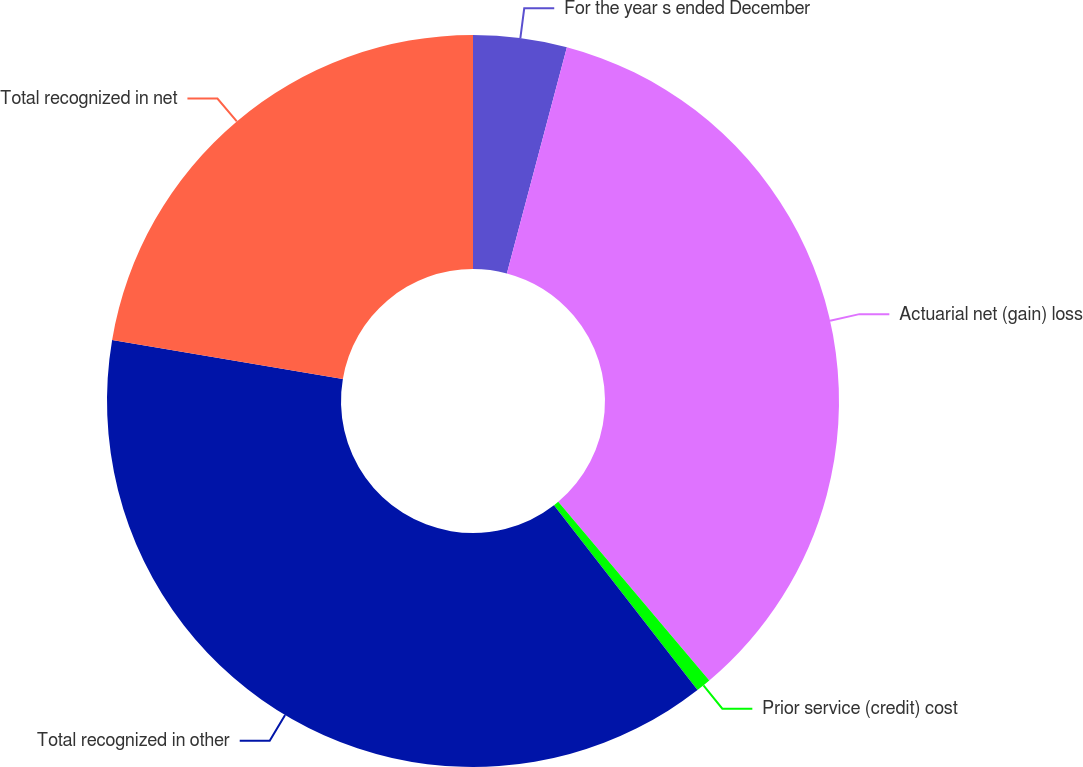<chart> <loc_0><loc_0><loc_500><loc_500><pie_chart><fcel>For the year s ended December<fcel>Actuarial net (gain) loss<fcel>Prior service (credit) cost<fcel>Total recognized in other<fcel>Total recognized in net<nl><fcel>4.13%<fcel>34.7%<fcel>0.66%<fcel>38.18%<fcel>22.33%<nl></chart> 